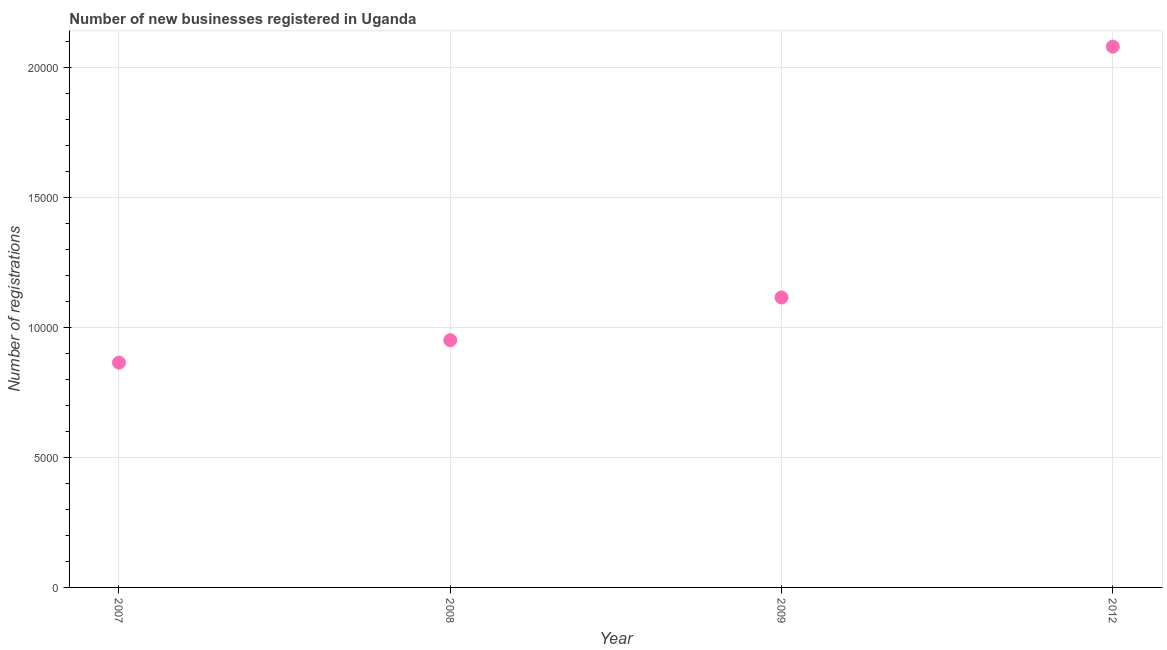What is the number of new business registrations in 2008?
Your answer should be very brief. 9509. Across all years, what is the maximum number of new business registrations?
Provide a short and direct response. 2.08e+04. Across all years, what is the minimum number of new business registrations?
Your answer should be very brief. 8645. What is the sum of the number of new business registrations?
Give a very brief answer. 5.01e+04. What is the difference between the number of new business registrations in 2007 and 2012?
Make the answer very short. -1.22e+04. What is the average number of new business registrations per year?
Offer a terse response. 1.25e+04. What is the median number of new business registrations?
Your answer should be compact. 1.03e+04. What is the ratio of the number of new business registrations in 2008 to that in 2009?
Your response must be concise. 0.85. What is the difference between the highest and the second highest number of new business registrations?
Offer a very short reply. 9648. Is the sum of the number of new business registrations in 2008 and 2012 greater than the maximum number of new business registrations across all years?
Ensure brevity in your answer.  Yes. What is the difference between the highest and the lowest number of new business registrations?
Provide a succinct answer. 1.22e+04. How many years are there in the graph?
Offer a very short reply. 4. What is the difference between two consecutive major ticks on the Y-axis?
Ensure brevity in your answer.  5000. Are the values on the major ticks of Y-axis written in scientific E-notation?
Offer a terse response. No. Does the graph contain any zero values?
Give a very brief answer. No. Does the graph contain grids?
Provide a succinct answer. Yes. What is the title of the graph?
Make the answer very short. Number of new businesses registered in Uganda. What is the label or title of the X-axis?
Ensure brevity in your answer.  Year. What is the label or title of the Y-axis?
Your answer should be compact. Number of registrations. What is the Number of registrations in 2007?
Give a very brief answer. 8645. What is the Number of registrations in 2008?
Your answer should be compact. 9509. What is the Number of registrations in 2009?
Offer a terse response. 1.12e+04. What is the Number of registrations in 2012?
Your answer should be compact. 2.08e+04. What is the difference between the Number of registrations in 2007 and 2008?
Your response must be concise. -864. What is the difference between the Number of registrations in 2007 and 2009?
Provide a short and direct response. -2507. What is the difference between the Number of registrations in 2007 and 2012?
Offer a very short reply. -1.22e+04. What is the difference between the Number of registrations in 2008 and 2009?
Offer a very short reply. -1643. What is the difference between the Number of registrations in 2008 and 2012?
Provide a short and direct response. -1.13e+04. What is the difference between the Number of registrations in 2009 and 2012?
Your response must be concise. -9648. What is the ratio of the Number of registrations in 2007 to that in 2008?
Give a very brief answer. 0.91. What is the ratio of the Number of registrations in 2007 to that in 2009?
Give a very brief answer. 0.78. What is the ratio of the Number of registrations in 2007 to that in 2012?
Offer a very short reply. 0.42. What is the ratio of the Number of registrations in 2008 to that in 2009?
Provide a succinct answer. 0.85. What is the ratio of the Number of registrations in 2008 to that in 2012?
Your answer should be very brief. 0.46. What is the ratio of the Number of registrations in 2009 to that in 2012?
Give a very brief answer. 0.54. 